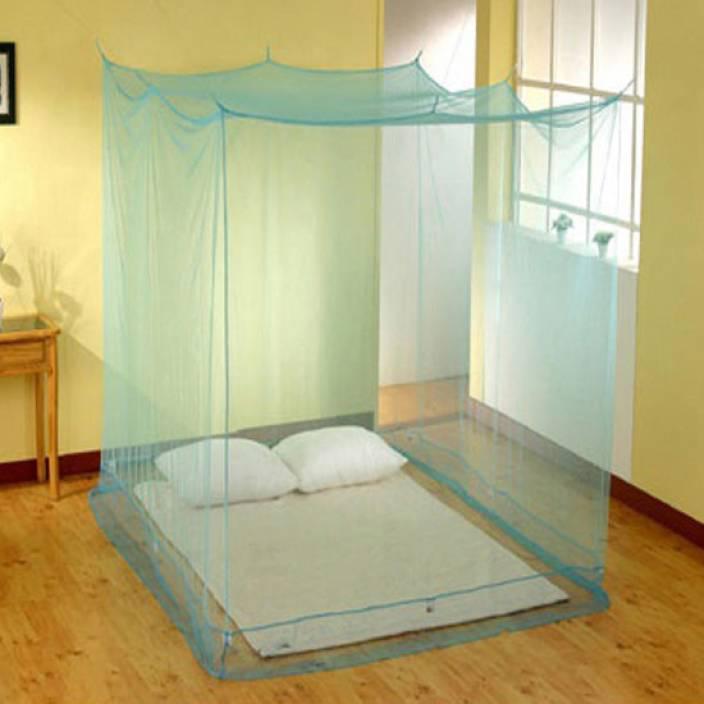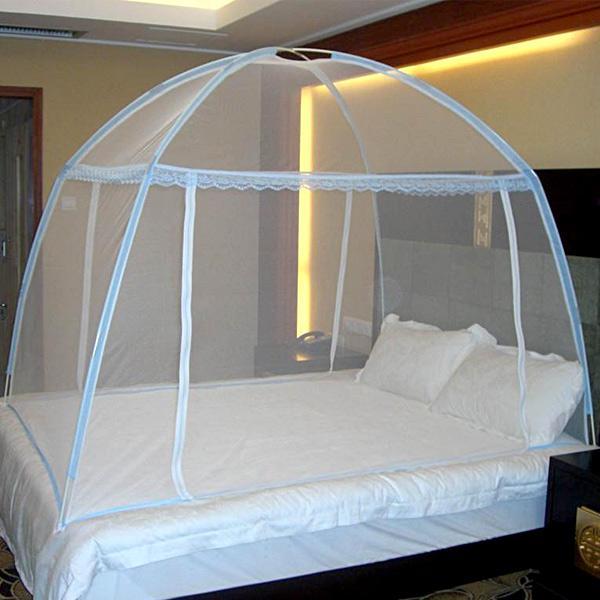The first image is the image on the left, the second image is the image on the right. For the images shown, is this caption "There is a square canopy over a mattress on the floor" true? Answer yes or no. Yes. The first image is the image on the left, the second image is the image on the right. Considering the images on both sides, is "At least one of the nets is blue." valid? Answer yes or no. Yes. 